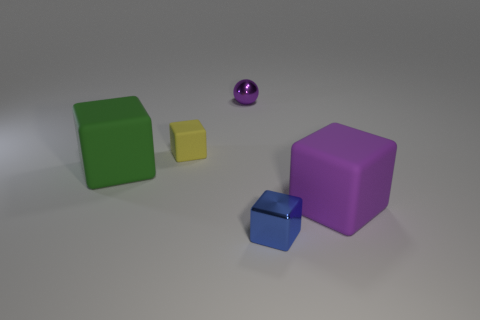Subtract all matte cubes. How many cubes are left? 1 Add 2 yellow things. How many objects exist? 7 Subtract all purple blocks. How many blocks are left? 3 Subtract 4 blocks. How many blocks are left? 0 Subtract all balls. How many objects are left? 4 Subtract all tiny purple objects. Subtract all tiny yellow cubes. How many objects are left? 3 Add 5 tiny metallic balls. How many tiny metallic balls are left? 6 Add 4 green cubes. How many green cubes exist? 5 Subtract 1 purple spheres. How many objects are left? 4 Subtract all yellow cubes. Subtract all brown cylinders. How many cubes are left? 3 